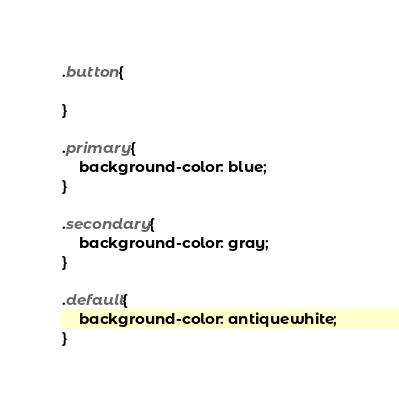<code> <loc_0><loc_0><loc_500><loc_500><_CSS_>.button{

}

.primary{
    background-color: blue;
}

.secondary{
    background-color: gray;
}

.default{
    background-color: antiquewhite;
}</code> 